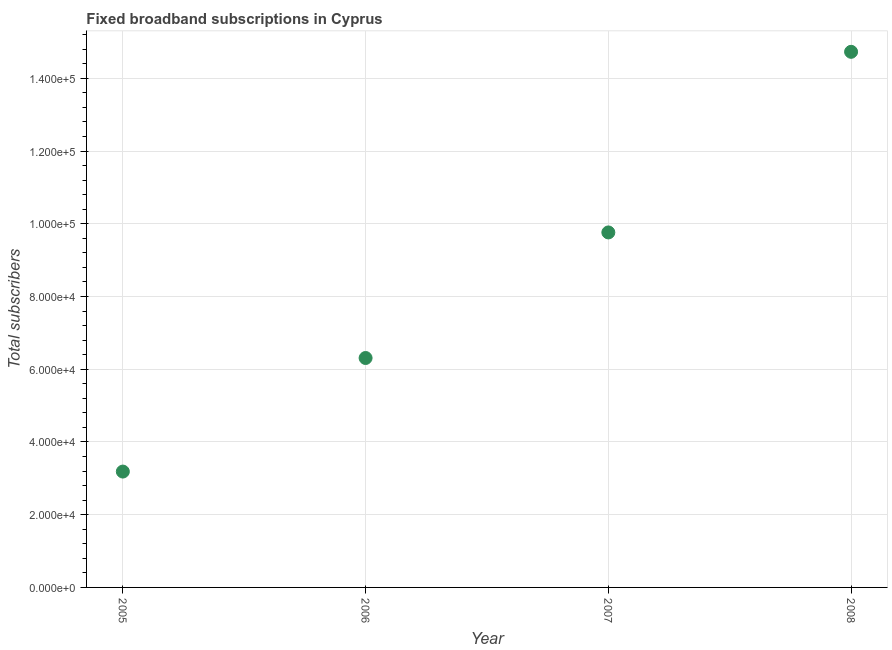What is the total number of fixed broadband subscriptions in 2007?
Offer a terse response. 9.76e+04. Across all years, what is the maximum total number of fixed broadband subscriptions?
Your answer should be very brief. 1.47e+05. Across all years, what is the minimum total number of fixed broadband subscriptions?
Provide a succinct answer. 3.19e+04. In which year was the total number of fixed broadband subscriptions maximum?
Keep it short and to the point. 2008. In which year was the total number of fixed broadband subscriptions minimum?
Keep it short and to the point. 2005. What is the sum of the total number of fixed broadband subscriptions?
Keep it short and to the point. 3.40e+05. What is the difference between the total number of fixed broadband subscriptions in 2006 and 2008?
Offer a very short reply. -8.42e+04. What is the average total number of fixed broadband subscriptions per year?
Your answer should be very brief. 8.50e+04. What is the median total number of fixed broadband subscriptions?
Ensure brevity in your answer.  8.03e+04. In how many years, is the total number of fixed broadband subscriptions greater than 4000 ?
Your answer should be very brief. 4. Do a majority of the years between 2006 and 2008 (inclusive) have total number of fixed broadband subscriptions greater than 128000 ?
Your answer should be very brief. No. What is the ratio of the total number of fixed broadband subscriptions in 2007 to that in 2008?
Make the answer very short. 0.66. Is the difference between the total number of fixed broadband subscriptions in 2007 and 2008 greater than the difference between any two years?
Provide a succinct answer. No. What is the difference between the highest and the second highest total number of fixed broadband subscriptions?
Your answer should be compact. 4.97e+04. Is the sum of the total number of fixed broadband subscriptions in 2005 and 2006 greater than the maximum total number of fixed broadband subscriptions across all years?
Keep it short and to the point. No. What is the difference between the highest and the lowest total number of fixed broadband subscriptions?
Give a very brief answer. 1.15e+05. In how many years, is the total number of fixed broadband subscriptions greater than the average total number of fixed broadband subscriptions taken over all years?
Give a very brief answer. 2. Does the total number of fixed broadband subscriptions monotonically increase over the years?
Provide a short and direct response. Yes. How many dotlines are there?
Provide a short and direct response. 1. How many years are there in the graph?
Keep it short and to the point. 4. Are the values on the major ticks of Y-axis written in scientific E-notation?
Offer a terse response. Yes. Does the graph contain grids?
Your answer should be very brief. Yes. What is the title of the graph?
Ensure brevity in your answer.  Fixed broadband subscriptions in Cyprus. What is the label or title of the X-axis?
Your answer should be compact. Year. What is the label or title of the Y-axis?
Your answer should be compact. Total subscribers. What is the Total subscribers in 2005?
Keep it short and to the point. 3.19e+04. What is the Total subscribers in 2006?
Provide a succinct answer. 6.31e+04. What is the Total subscribers in 2007?
Keep it short and to the point. 9.76e+04. What is the Total subscribers in 2008?
Ensure brevity in your answer.  1.47e+05. What is the difference between the Total subscribers in 2005 and 2006?
Provide a succinct answer. -3.12e+04. What is the difference between the Total subscribers in 2005 and 2007?
Provide a succinct answer. -6.58e+04. What is the difference between the Total subscribers in 2005 and 2008?
Offer a terse response. -1.15e+05. What is the difference between the Total subscribers in 2006 and 2007?
Your answer should be very brief. -3.45e+04. What is the difference between the Total subscribers in 2006 and 2008?
Your response must be concise. -8.42e+04. What is the difference between the Total subscribers in 2007 and 2008?
Your answer should be compact. -4.97e+04. What is the ratio of the Total subscribers in 2005 to that in 2006?
Offer a terse response. 0.51. What is the ratio of the Total subscribers in 2005 to that in 2007?
Ensure brevity in your answer.  0.33. What is the ratio of the Total subscribers in 2005 to that in 2008?
Offer a terse response. 0.22. What is the ratio of the Total subscribers in 2006 to that in 2007?
Provide a succinct answer. 0.65. What is the ratio of the Total subscribers in 2006 to that in 2008?
Offer a very short reply. 0.43. What is the ratio of the Total subscribers in 2007 to that in 2008?
Your response must be concise. 0.66. 